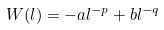Convert formula to latex. <formula><loc_0><loc_0><loc_500><loc_500>W ( l ) = - a l ^ { - p } + b l ^ { - q }</formula> 